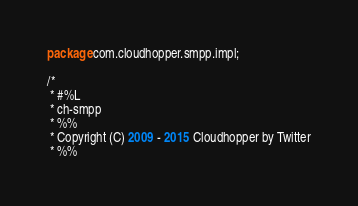<code> <loc_0><loc_0><loc_500><loc_500><_Java_>package com.cloudhopper.smpp.impl;

/*
 * #%L
 * ch-smpp
 * %%
 * Copyright (C) 2009 - 2015 Cloudhopper by Twitter
 * %%</code> 